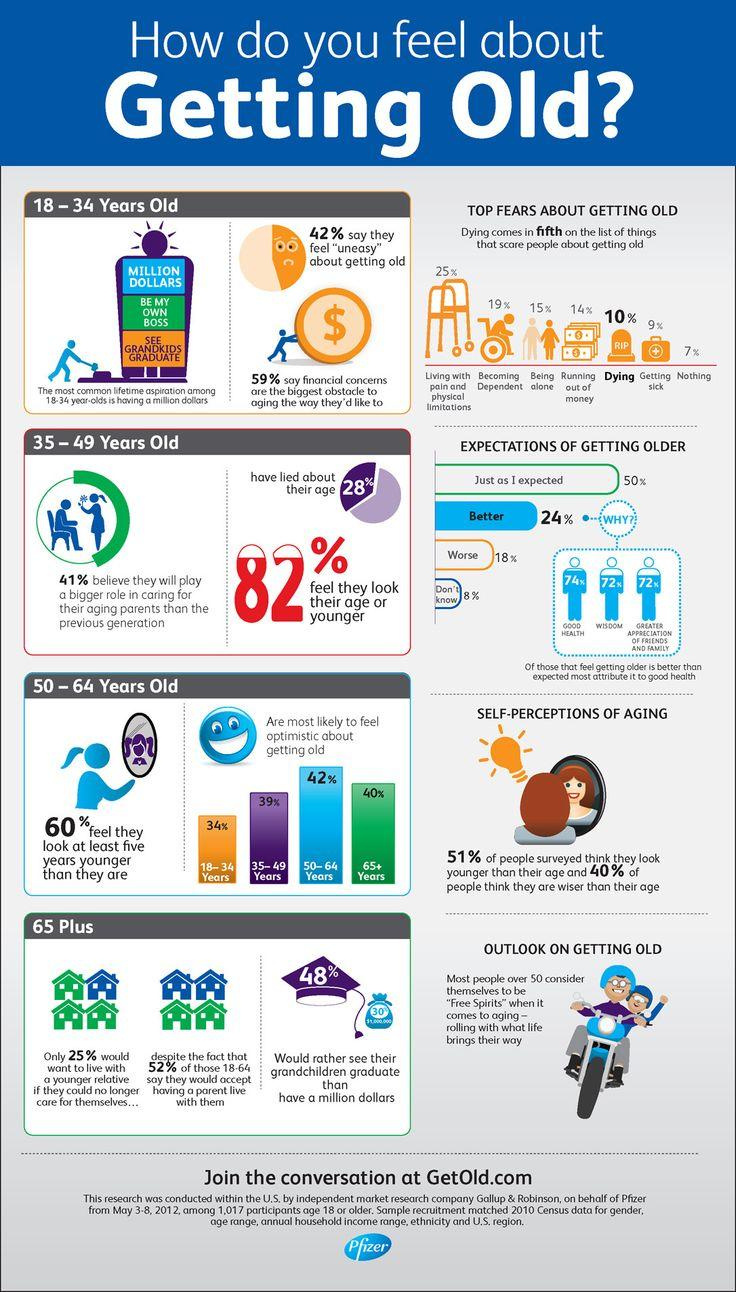Point out several critical features in this image. The 65+ age group is the second age group that feels optimistic about getting old. Sixty percent of people do not believe they are wiser than they are in age. A significant percentage of people did not lie about their age, with 18% of individuals being truthful about their age. 